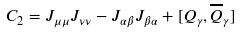<formula> <loc_0><loc_0><loc_500><loc_500>C _ { 2 } = J _ { \mu \mu } J _ { \nu \nu } - J _ { \alpha \beta } J _ { \beta \alpha } + [ Q _ { \gamma } , \overline { Q } _ { \gamma } ]</formula> 